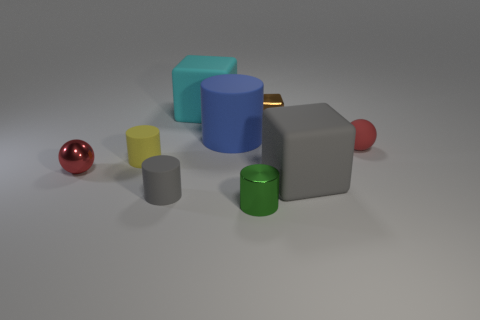Is the color of the tiny ball in front of the yellow cylinder the same as the matte ball?
Offer a very short reply. Yes. There is a yellow rubber thing that is in front of the blue object; does it have the same size as the tiny gray cylinder?
Offer a very short reply. Yes. What color is the tiny metal object that is both to the right of the red metal sphere and in front of the tiny yellow object?
Your answer should be compact. Green. What shape is the yellow matte thing that is the same size as the metal sphere?
Your response must be concise. Cylinder. Do the small metal ball and the rubber ball have the same color?
Your answer should be very brief. Yes. What is the size of the rubber thing that is both on the right side of the big cyan object and to the left of the tiny brown metallic block?
Make the answer very short. Large. What color is the small block that is made of the same material as the small green cylinder?
Your answer should be compact. Brown. Is the number of large rubber cylinders that are right of the brown metallic cube the same as the number of green cylinders that are on the right side of the tiny red matte sphere?
Your answer should be very brief. Yes. There is a tiny green object; is it the same shape as the gray thing to the left of the small brown shiny block?
Ensure brevity in your answer.  Yes. What is the material of the other ball that is the same color as the tiny metal ball?
Provide a short and direct response. Rubber. 